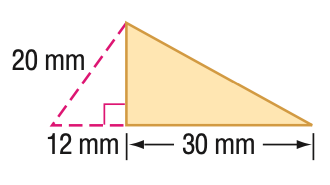Answer the mathemtical geometry problem and directly provide the correct option letter.
Question: Find the area of the triangle. Round to the nearest tenth if necessary.
Choices: A: 180 B: 240 C: 360 D: 480 B 